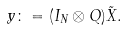<formula> <loc_0><loc_0><loc_500><loc_500>y \colon = ( I _ { N } \otimes Q ) \tilde { X } .</formula> 